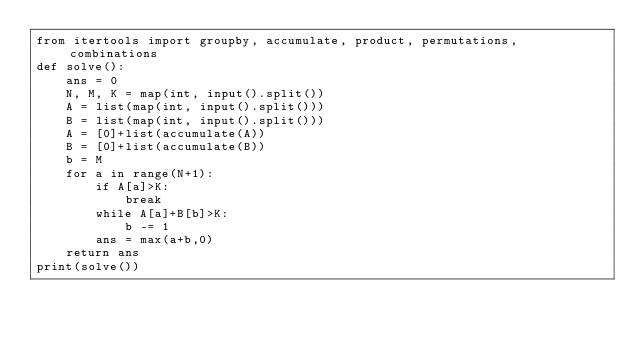<code> <loc_0><loc_0><loc_500><loc_500><_Python_>from itertools import groupby, accumulate, product, permutations, combinations
def solve():
    ans = 0
    N, M, K = map(int, input().split())
    A = list(map(int, input().split()))
    B = list(map(int, input().split()))
    A = [0]+list(accumulate(A))
    B = [0]+list(accumulate(B))
    b = M
    for a in range(N+1):
        if A[a]>K:
            break
        while A[a]+B[b]>K:
            b -= 1
        ans = max(a+b,0)
    return ans
print(solve())</code> 